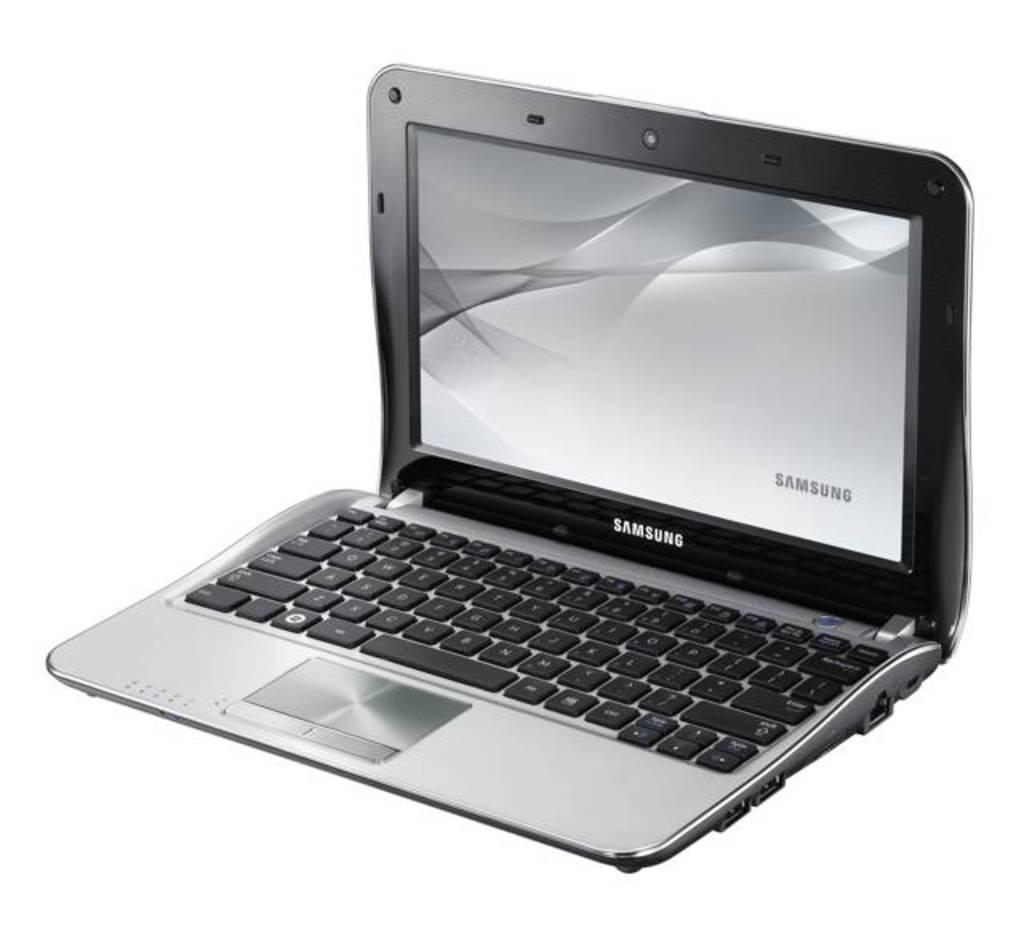<image>
Create a compact narrative representing the image presented. A chrome and black laptop by the brand Samsung. 